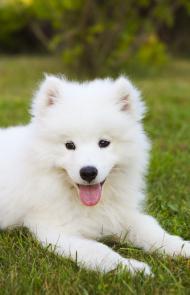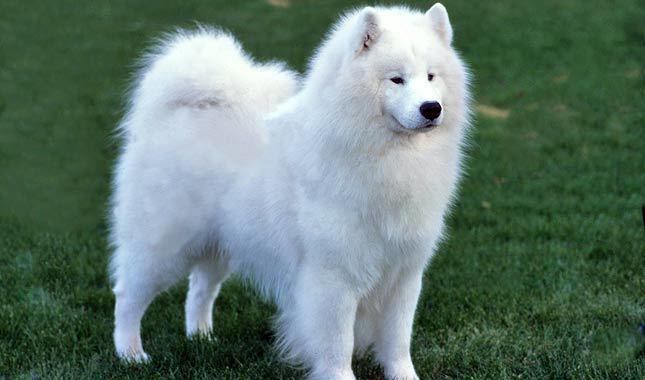The first image is the image on the left, the second image is the image on the right. For the images displayed, is the sentence "One image features one or more white dogs reclining on grass." factually correct? Answer yes or no. Yes. 